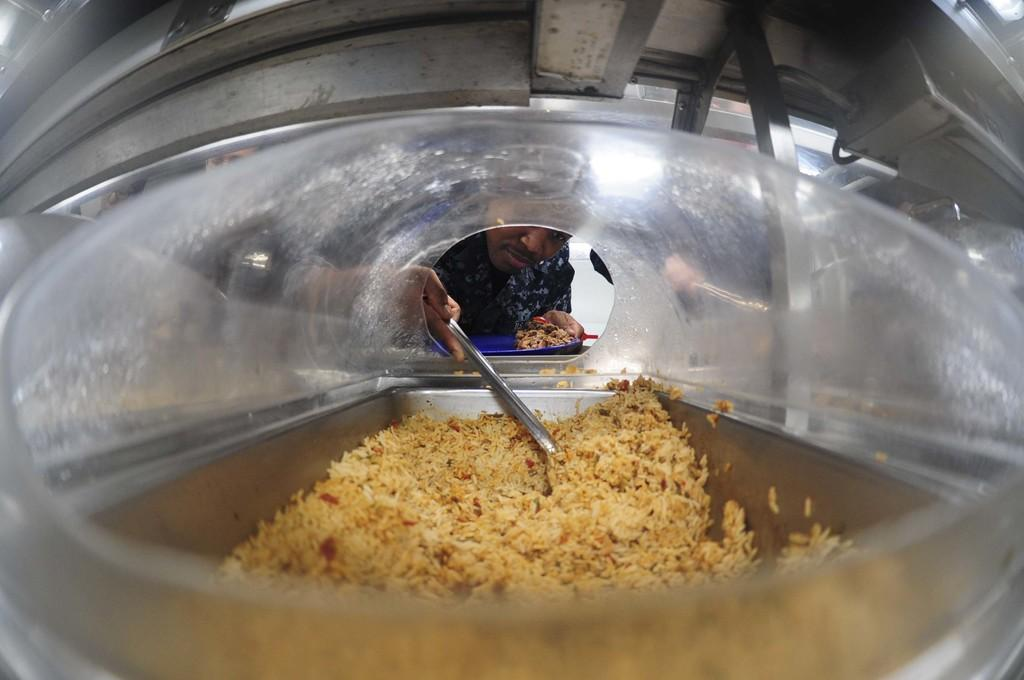Who is present in the image? There is a man in the image. What is the man holding in his hand? The man is holding a plate with food and a spatula. What else can be seen in the image related to food? There is food in a steel container in the image. How many bubbles are floating around the man in the image? There are no bubbles present in the image. What type of planes can be seen flying in the background of the image? There are no planes visible in the image. 